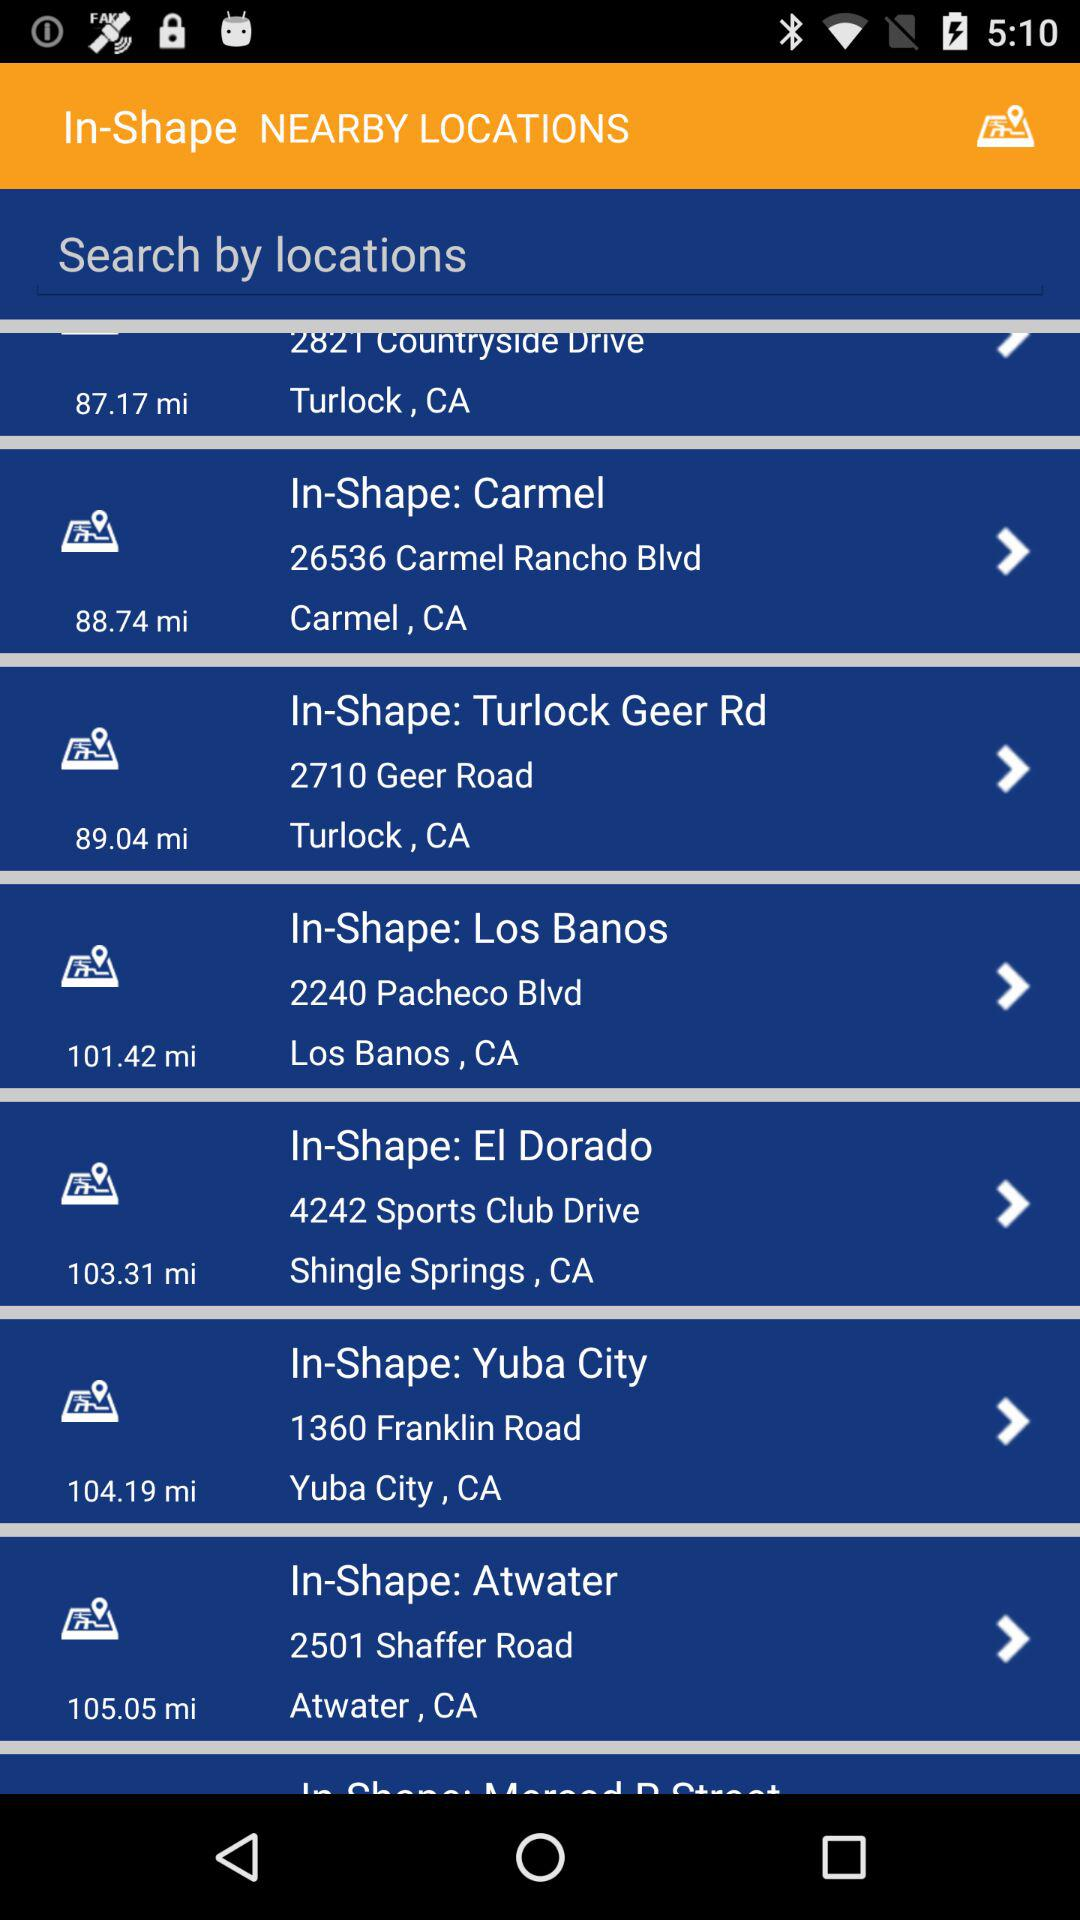What is the address of In-Shape in El Dorado? The address is 4242 Sports Club Drive, Shingle Springs, CA. 